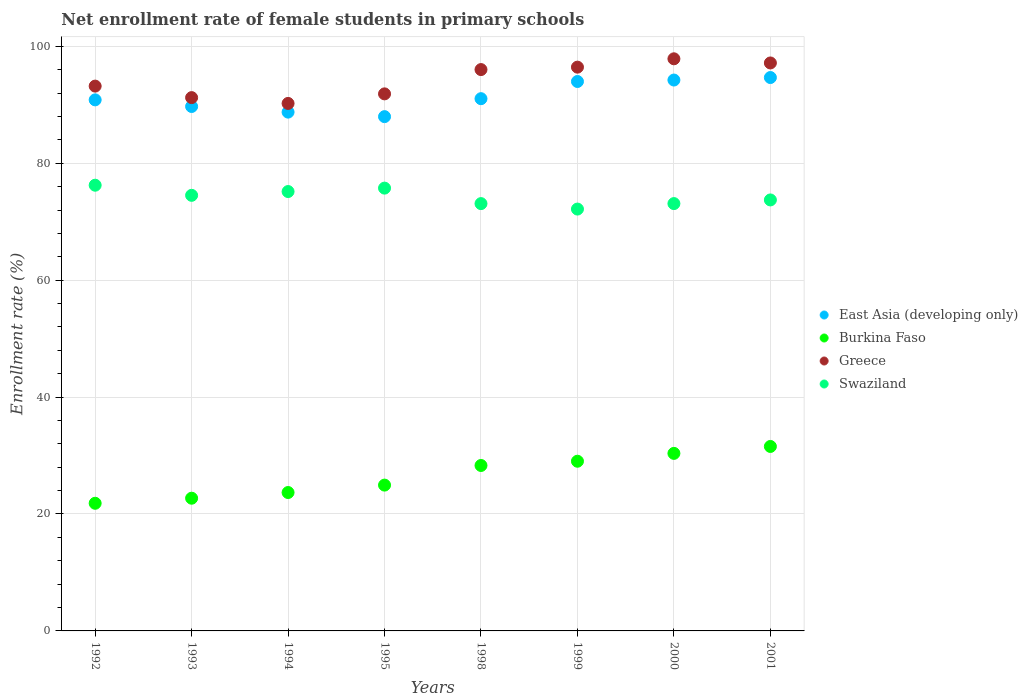Is the number of dotlines equal to the number of legend labels?
Give a very brief answer. Yes. What is the net enrollment rate of female students in primary schools in Swaziland in 1994?
Offer a terse response. 75.16. Across all years, what is the maximum net enrollment rate of female students in primary schools in Greece?
Your response must be concise. 97.86. Across all years, what is the minimum net enrollment rate of female students in primary schools in Swaziland?
Provide a short and direct response. 72.16. What is the total net enrollment rate of female students in primary schools in Swaziland in the graph?
Provide a succinct answer. 593.72. What is the difference between the net enrollment rate of female students in primary schools in Burkina Faso in 1992 and that in 2000?
Offer a terse response. -8.54. What is the difference between the net enrollment rate of female students in primary schools in Swaziland in 1992 and the net enrollment rate of female students in primary schools in Greece in 2000?
Make the answer very short. -21.62. What is the average net enrollment rate of female students in primary schools in Greece per year?
Offer a terse response. 94.25. In the year 1994, what is the difference between the net enrollment rate of female students in primary schools in Burkina Faso and net enrollment rate of female students in primary schools in East Asia (developing only)?
Offer a terse response. -65.07. What is the ratio of the net enrollment rate of female students in primary schools in Greece in 1993 to that in 2000?
Keep it short and to the point. 0.93. What is the difference between the highest and the second highest net enrollment rate of female students in primary schools in East Asia (developing only)?
Ensure brevity in your answer.  0.43. What is the difference between the highest and the lowest net enrollment rate of female students in primary schools in Greece?
Ensure brevity in your answer.  7.63. Is the sum of the net enrollment rate of female students in primary schools in Swaziland in 1992 and 2001 greater than the maximum net enrollment rate of female students in primary schools in East Asia (developing only) across all years?
Provide a succinct answer. Yes. Does the net enrollment rate of female students in primary schools in Burkina Faso monotonically increase over the years?
Keep it short and to the point. Yes. Is the net enrollment rate of female students in primary schools in Swaziland strictly greater than the net enrollment rate of female students in primary schools in East Asia (developing only) over the years?
Your answer should be very brief. No. How many dotlines are there?
Your answer should be compact. 4. How many years are there in the graph?
Your response must be concise. 8. What is the difference between two consecutive major ticks on the Y-axis?
Offer a terse response. 20. Are the values on the major ticks of Y-axis written in scientific E-notation?
Make the answer very short. No. Does the graph contain any zero values?
Provide a short and direct response. No. Does the graph contain grids?
Your answer should be compact. Yes. How many legend labels are there?
Provide a short and direct response. 4. How are the legend labels stacked?
Offer a very short reply. Vertical. What is the title of the graph?
Make the answer very short. Net enrollment rate of female students in primary schools. Does "Djibouti" appear as one of the legend labels in the graph?
Provide a short and direct response. No. What is the label or title of the Y-axis?
Offer a terse response. Enrollment rate (%). What is the Enrollment rate (%) in East Asia (developing only) in 1992?
Offer a very short reply. 90.84. What is the Enrollment rate (%) of Burkina Faso in 1992?
Give a very brief answer. 21.83. What is the Enrollment rate (%) in Greece in 1992?
Give a very brief answer. 93.19. What is the Enrollment rate (%) in Swaziland in 1992?
Provide a short and direct response. 76.24. What is the Enrollment rate (%) in East Asia (developing only) in 1993?
Your answer should be very brief. 89.71. What is the Enrollment rate (%) in Burkina Faso in 1993?
Provide a short and direct response. 22.7. What is the Enrollment rate (%) in Greece in 1993?
Provide a succinct answer. 91.22. What is the Enrollment rate (%) in Swaziland in 1993?
Your answer should be very brief. 74.51. What is the Enrollment rate (%) of East Asia (developing only) in 1994?
Your answer should be very brief. 88.74. What is the Enrollment rate (%) in Burkina Faso in 1994?
Make the answer very short. 23.67. What is the Enrollment rate (%) of Greece in 1994?
Make the answer very short. 90.23. What is the Enrollment rate (%) in Swaziland in 1994?
Make the answer very short. 75.16. What is the Enrollment rate (%) in East Asia (developing only) in 1995?
Offer a very short reply. 87.97. What is the Enrollment rate (%) of Burkina Faso in 1995?
Offer a terse response. 24.94. What is the Enrollment rate (%) in Greece in 1995?
Give a very brief answer. 91.86. What is the Enrollment rate (%) in Swaziland in 1995?
Offer a very short reply. 75.74. What is the Enrollment rate (%) of East Asia (developing only) in 1998?
Offer a very short reply. 91.04. What is the Enrollment rate (%) in Burkina Faso in 1998?
Your answer should be compact. 28.3. What is the Enrollment rate (%) of Greece in 1998?
Your answer should be compact. 96.02. What is the Enrollment rate (%) in Swaziland in 1998?
Offer a very short reply. 73.09. What is the Enrollment rate (%) in East Asia (developing only) in 1999?
Your response must be concise. 93.98. What is the Enrollment rate (%) in Burkina Faso in 1999?
Offer a terse response. 29.03. What is the Enrollment rate (%) in Greece in 1999?
Make the answer very short. 96.44. What is the Enrollment rate (%) of Swaziland in 1999?
Keep it short and to the point. 72.16. What is the Enrollment rate (%) in East Asia (developing only) in 2000?
Offer a terse response. 94.23. What is the Enrollment rate (%) in Burkina Faso in 2000?
Offer a very short reply. 30.37. What is the Enrollment rate (%) of Greece in 2000?
Provide a succinct answer. 97.86. What is the Enrollment rate (%) of Swaziland in 2000?
Provide a succinct answer. 73.1. What is the Enrollment rate (%) of East Asia (developing only) in 2001?
Your answer should be very brief. 94.66. What is the Enrollment rate (%) in Burkina Faso in 2001?
Provide a succinct answer. 31.55. What is the Enrollment rate (%) of Greece in 2001?
Offer a terse response. 97.15. What is the Enrollment rate (%) of Swaziland in 2001?
Your response must be concise. 73.72. Across all years, what is the maximum Enrollment rate (%) in East Asia (developing only)?
Keep it short and to the point. 94.66. Across all years, what is the maximum Enrollment rate (%) of Burkina Faso?
Your answer should be very brief. 31.55. Across all years, what is the maximum Enrollment rate (%) in Greece?
Your answer should be very brief. 97.86. Across all years, what is the maximum Enrollment rate (%) in Swaziland?
Give a very brief answer. 76.24. Across all years, what is the minimum Enrollment rate (%) of East Asia (developing only)?
Make the answer very short. 87.97. Across all years, what is the minimum Enrollment rate (%) of Burkina Faso?
Offer a very short reply. 21.83. Across all years, what is the minimum Enrollment rate (%) of Greece?
Give a very brief answer. 90.23. Across all years, what is the minimum Enrollment rate (%) in Swaziland?
Your answer should be compact. 72.16. What is the total Enrollment rate (%) in East Asia (developing only) in the graph?
Offer a terse response. 731.17. What is the total Enrollment rate (%) of Burkina Faso in the graph?
Offer a very short reply. 212.4. What is the total Enrollment rate (%) in Greece in the graph?
Give a very brief answer. 753.98. What is the total Enrollment rate (%) of Swaziland in the graph?
Make the answer very short. 593.72. What is the difference between the Enrollment rate (%) of East Asia (developing only) in 1992 and that in 1993?
Your answer should be compact. 1.13. What is the difference between the Enrollment rate (%) in Burkina Faso in 1992 and that in 1993?
Make the answer very short. -0.87. What is the difference between the Enrollment rate (%) in Greece in 1992 and that in 1993?
Offer a terse response. 1.97. What is the difference between the Enrollment rate (%) in Swaziland in 1992 and that in 1993?
Your answer should be compact. 1.73. What is the difference between the Enrollment rate (%) of East Asia (developing only) in 1992 and that in 1994?
Offer a terse response. 2.1. What is the difference between the Enrollment rate (%) in Burkina Faso in 1992 and that in 1994?
Make the answer very short. -1.84. What is the difference between the Enrollment rate (%) in Greece in 1992 and that in 1994?
Give a very brief answer. 2.96. What is the difference between the Enrollment rate (%) in Swaziland in 1992 and that in 1994?
Your answer should be very brief. 1.08. What is the difference between the Enrollment rate (%) of East Asia (developing only) in 1992 and that in 1995?
Provide a succinct answer. 2.87. What is the difference between the Enrollment rate (%) of Burkina Faso in 1992 and that in 1995?
Keep it short and to the point. -3.11. What is the difference between the Enrollment rate (%) of Greece in 1992 and that in 1995?
Offer a very short reply. 1.33. What is the difference between the Enrollment rate (%) in Swaziland in 1992 and that in 1995?
Your response must be concise. 0.5. What is the difference between the Enrollment rate (%) of East Asia (developing only) in 1992 and that in 1998?
Ensure brevity in your answer.  -0.2. What is the difference between the Enrollment rate (%) in Burkina Faso in 1992 and that in 1998?
Offer a very short reply. -6.46. What is the difference between the Enrollment rate (%) of Greece in 1992 and that in 1998?
Provide a succinct answer. -2.83. What is the difference between the Enrollment rate (%) of Swaziland in 1992 and that in 1998?
Offer a very short reply. 3.15. What is the difference between the Enrollment rate (%) of East Asia (developing only) in 1992 and that in 1999?
Keep it short and to the point. -3.14. What is the difference between the Enrollment rate (%) of Burkina Faso in 1992 and that in 1999?
Provide a succinct answer. -7.19. What is the difference between the Enrollment rate (%) in Greece in 1992 and that in 1999?
Provide a succinct answer. -3.24. What is the difference between the Enrollment rate (%) in Swaziland in 1992 and that in 1999?
Your answer should be compact. 4.08. What is the difference between the Enrollment rate (%) of East Asia (developing only) in 1992 and that in 2000?
Offer a terse response. -3.39. What is the difference between the Enrollment rate (%) in Burkina Faso in 1992 and that in 2000?
Your response must be concise. -8.54. What is the difference between the Enrollment rate (%) of Greece in 1992 and that in 2000?
Your response must be concise. -4.67. What is the difference between the Enrollment rate (%) in Swaziland in 1992 and that in 2000?
Provide a short and direct response. 3.14. What is the difference between the Enrollment rate (%) in East Asia (developing only) in 1992 and that in 2001?
Make the answer very short. -3.82. What is the difference between the Enrollment rate (%) in Burkina Faso in 1992 and that in 2001?
Your response must be concise. -9.72. What is the difference between the Enrollment rate (%) of Greece in 1992 and that in 2001?
Your answer should be very brief. -3.96. What is the difference between the Enrollment rate (%) in Swaziland in 1992 and that in 2001?
Ensure brevity in your answer.  2.52. What is the difference between the Enrollment rate (%) in East Asia (developing only) in 1993 and that in 1994?
Give a very brief answer. 0.96. What is the difference between the Enrollment rate (%) of Burkina Faso in 1993 and that in 1994?
Give a very brief answer. -0.97. What is the difference between the Enrollment rate (%) in Greece in 1993 and that in 1994?
Ensure brevity in your answer.  0.99. What is the difference between the Enrollment rate (%) of Swaziland in 1993 and that in 1994?
Offer a terse response. -0.65. What is the difference between the Enrollment rate (%) in East Asia (developing only) in 1993 and that in 1995?
Your answer should be compact. 1.74. What is the difference between the Enrollment rate (%) in Burkina Faso in 1993 and that in 1995?
Offer a terse response. -2.24. What is the difference between the Enrollment rate (%) in Greece in 1993 and that in 1995?
Offer a terse response. -0.64. What is the difference between the Enrollment rate (%) of Swaziland in 1993 and that in 1995?
Your answer should be compact. -1.23. What is the difference between the Enrollment rate (%) of East Asia (developing only) in 1993 and that in 1998?
Provide a succinct answer. -1.34. What is the difference between the Enrollment rate (%) in Burkina Faso in 1993 and that in 1998?
Provide a succinct answer. -5.6. What is the difference between the Enrollment rate (%) in Greece in 1993 and that in 1998?
Make the answer very short. -4.8. What is the difference between the Enrollment rate (%) in Swaziland in 1993 and that in 1998?
Give a very brief answer. 1.42. What is the difference between the Enrollment rate (%) in East Asia (developing only) in 1993 and that in 1999?
Give a very brief answer. -4.28. What is the difference between the Enrollment rate (%) of Burkina Faso in 1993 and that in 1999?
Give a very brief answer. -6.33. What is the difference between the Enrollment rate (%) of Greece in 1993 and that in 1999?
Offer a terse response. -5.21. What is the difference between the Enrollment rate (%) in Swaziland in 1993 and that in 1999?
Give a very brief answer. 2.35. What is the difference between the Enrollment rate (%) in East Asia (developing only) in 1993 and that in 2000?
Keep it short and to the point. -4.53. What is the difference between the Enrollment rate (%) in Burkina Faso in 1993 and that in 2000?
Offer a very short reply. -7.67. What is the difference between the Enrollment rate (%) of Greece in 1993 and that in 2000?
Ensure brevity in your answer.  -6.64. What is the difference between the Enrollment rate (%) in Swaziland in 1993 and that in 2000?
Your response must be concise. 1.41. What is the difference between the Enrollment rate (%) in East Asia (developing only) in 1993 and that in 2001?
Ensure brevity in your answer.  -4.95. What is the difference between the Enrollment rate (%) of Burkina Faso in 1993 and that in 2001?
Keep it short and to the point. -8.85. What is the difference between the Enrollment rate (%) of Greece in 1993 and that in 2001?
Provide a short and direct response. -5.93. What is the difference between the Enrollment rate (%) of Swaziland in 1993 and that in 2001?
Give a very brief answer. 0.79. What is the difference between the Enrollment rate (%) in East Asia (developing only) in 1994 and that in 1995?
Give a very brief answer. 0.77. What is the difference between the Enrollment rate (%) of Burkina Faso in 1994 and that in 1995?
Ensure brevity in your answer.  -1.27. What is the difference between the Enrollment rate (%) in Greece in 1994 and that in 1995?
Give a very brief answer. -1.64. What is the difference between the Enrollment rate (%) of Swaziland in 1994 and that in 1995?
Your answer should be compact. -0.58. What is the difference between the Enrollment rate (%) in East Asia (developing only) in 1994 and that in 1998?
Provide a short and direct response. -2.3. What is the difference between the Enrollment rate (%) of Burkina Faso in 1994 and that in 1998?
Give a very brief answer. -4.62. What is the difference between the Enrollment rate (%) of Greece in 1994 and that in 1998?
Provide a short and direct response. -5.79. What is the difference between the Enrollment rate (%) of Swaziland in 1994 and that in 1998?
Offer a terse response. 2.07. What is the difference between the Enrollment rate (%) of East Asia (developing only) in 1994 and that in 1999?
Keep it short and to the point. -5.24. What is the difference between the Enrollment rate (%) in Burkina Faso in 1994 and that in 1999?
Your response must be concise. -5.35. What is the difference between the Enrollment rate (%) in Greece in 1994 and that in 1999?
Give a very brief answer. -6.21. What is the difference between the Enrollment rate (%) of Swaziland in 1994 and that in 1999?
Make the answer very short. 3. What is the difference between the Enrollment rate (%) of East Asia (developing only) in 1994 and that in 2000?
Provide a short and direct response. -5.49. What is the difference between the Enrollment rate (%) in Burkina Faso in 1994 and that in 2000?
Provide a short and direct response. -6.7. What is the difference between the Enrollment rate (%) in Greece in 1994 and that in 2000?
Keep it short and to the point. -7.63. What is the difference between the Enrollment rate (%) in Swaziland in 1994 and that in 2000?
Provide a short and direct response. 2.06. What is the difference between the Enrollment rate (%) of East Asia (developing only) in 1994 and that in 2001?
Offer a terse response. -5.92. What is the difference between the Enrollment rate (%) in Burkina Faso in 1994 and that in 2001?
Your answer should be compact. -7.88. What is the difference between the Enrollment rate (%) in Greece in 1994 and that in 2001?
Make the answer very short. -6.92. What is the difference between the Enrollment rate (%) in Swaziland in 1994 and that in 2001?
Your answer should be very brief. 1.44. What is the difference between the Enrollment rate (%) of East Asia (developing only) in 1995 and that in 1998?
Provide a succinct answer. -3.07. What is the difference between the Enrollment rate (%) of Burkina Faso in 1995 and that in 1998?
Offer a terse response. -3.36. What is the difference between the Enrollment rate (%) of Greece in 1995 and that in 1998?
Keep it short and to the point. -4.16. What is the difference between the Enrollment rate (%) in Swaziland in 1995 and that in 1998?
Your response must be concise. 2.65. What is the difference between the Enrollment rate (%) in East Asia (developing only) in 1995 and that in 1999?
Your answer should be very brief. -6.01. What is the difference between the Enrollment rate (%) of Burkina Faso in 1995 and that in 1999?
Offer a very short reply. -4.08. What is the difference between the Enrollment rate (%) of Greece in 1995 and that in 1999?
Give a very brief answer. -4.57. What is the difference between the Enrollment rate (%) of Swaziland in 1995 and that in 1999?
Your answer should be compact. 3.58. What is the difference between the Enrollment rate (%) in East Asia (developing only) in 1995 and that in 2000?
Keep it short and to the point. -6.26. What is the difference between the Enrollment rate (%) in Burkina Faso in 1995 and that in 2000?
Your response must be concise. -5.43. What is the difference between the Enrollment rate (%) of Greece in 1995 and that in 2000?
Your response must be concise. -6. What is the difference between the Enrollment rate (%) in Swaziland in 1995 and that in 2000?
Offer a very short reply. 2.65. What is the difference between the Enrollment rate (%) in East Asia (developing only) in 1995 and that in 2001?
Offer a terse response. -6.69. What is the difference between the Enrollment rate (%) in Burkina Faso in 1995 and that in 2001?
Provide a succinct answer. -6.61. What is the difference between the Enrollment rate (%) of Greece in 1995 and that in 2001?
Offer a terse response. -5.29. What is the difference between the Enrollment rate (%) in Swaziland in 1995 and that in 2001?
Keep it short and to the point. 2.02. What is the difference between the Enrollment rate (%) of East Asia (developing only) in 1998 and that in 1999?
Offer a terse response. -2.94. What is the difference between the Enrollment rate (%) of Burkina Faso in 1998 and that in 1999?
Keep it short and to the point. -0.73. What is the difference between the Enrollment rate (%) in Greece in 1998 and that in 1999?
Make the answer very short. -0.42. What is the difference between the Enrollment rate (%) in Swaziland in 1998 and that in 1999?
Keep it short and to the point. 0.93. What is the difference between the Enrollment rate (%) of East Asia (developing only) in 1998 and that in 2000?
Make the answer very short. -3.19. What is the difference between the Enrollment rate (%) in Burkina Faso in 1998 and that in 2000?
Provide a short and direct response. -2.07. What is the difference between the Enrollment rate (%) of Greece in 1998 and that in 2000?
Keep it short and to the point. -1.84. What is the difference between the Enrollment rate (%) in Swaziland in 1998 and that in 2000?
Make the answer very short. -0. What is the difference between the Enrollment rate (%) of East Asia (developing only) in 1998 and that in 2001?
Your answer should be very brief. -3.62. What is the difference between the Enrollment rate (%) in Burkina Faso in 1998 and that in 2001?
Provide a succinct answer. -3.26. What is the difference between the Enrollment rate (%) of Greece in 1998 and that in 2001?
Give a very brief answer. -1.13. What is the difference between the Enrollment rate (%) of Swaziland in 1998 and that in 2001?
Give a very brief answer. -0.63. What is the difference between the Enrollment rate (%) of East Asia (developing only) in 1999 and that in 2000?
Offer a terse response. -0.25. What is the difference between the Enrollment rate (%) in Burkina Faso in 1999 and that in 2000?
Offer a terse response. -1.34. What is the difference between the Enrollment rate (%) of Greece in 1999 and that in 2000?
Make the answer very short. -1.43. What is the difference between the Enrollment rate (%) in Swaziland in 1999 and that in 2000?
Make the answer very short. -0.94. What is the difference between the Enrollment rate (%) of East Asia (developing only) in 1999 and that in 2001?
Ensure brevity in your answer.  -0.68. What is the difference between the Enrollment rate (%) of Burkina Faso in 1999 and that in 2001?
Provide a short and direct response. -2.53. What is the difference between the Enrollment rate (%) of Greece in 1999 and that in 2001?
Provide a succinct answer. -0.72. What is the difference between the Enrollment rate (%) in Swaziland in 1999 and that in 2001?
Ensure brevity in your answer.  -1.56. What is the difference between the Enrollment rate (%) in East Asia (developing only) in 2000 and that in 2001?
Offer a very short reply. -0.43. What is the difference between the Enrollment rate (%) in Burkina Faso in 2000 and that in 2001?
Provide a short and direct response. -1.18. What is the difference between the Enrollment rate (%) in Greece in 2000 and that in 2001?
Keep it short and to the point. 0.71. What is the difference between the Enrollment rate (%) of Swaziland in 2000 and that in 2001?
Ensure brevity in your answer.  -0.62. What is the difference between the Enrollment rate (%) of East Asia (developing only) in 1992 and the Enrollment rate (%) of Burkina Faso in 1993?
Your answer should be compact. 68.14. What is the difference between the Enrollment rate (%) in East Asia (developing only) in 1992 and the Enrollment rate (%) in Greece in 1993?
Keep it short and to the point. -0.38. What is the difference between the Enrollment rate (%) in East Asia (developing only) in 1992 and the Enrollment rate (%) in Swaziland in 1993?
Ensure brevity in your answer.  16.33. What is the difference between the Enrollment rate (%) of Burkina Faso in 1992 and the Enrollment rate (%) of Greece in 1993?
Your answer should be very brief. -69.39. What is the difference between the Enrollment rate (%) in Burkina Faso in 1992 and the Enrollment rate (%) in Swaziland in 1993?
Offer a terse response. -52.68. What is the difference between the Enrollment rate (%) of Greece in 1992 and the Enrollment rate (%) of Swaziland in 1993?
Your response must be concise. 18.68. What is the difference between the Enrollment rate (%) of East Asia (developing only) in 1992 and the Enrollment rate (%) of Burkina Faso in 1994?
Provide a succinct answer. 67.17. What is the difference between the Enrollment rate (%) of East Asia (developing only) in 1992 and the Enrollment rate (%) of Greece in 1994?
Keep it short and to the point. 0.61. What is the difference between the Enrollment rate (%) in East Asia (developing only) in 1992 and the Enrollment rate (%) in Swaziland in 1994?
Give a very brief answer. 15.68. What is the difference between the Enrollment rate (%) of Burkina Faso in 1992 and the Enrollment rate (%) of Greece in 1994?
Provide a short and direct response. -68.4. What is the difference between the Enrollment rate (%) of Burkina Faso in 1992 and the Enrollment rate (%) of Swaziland in 1994?
Provide a succinct answer. -53.32. What is the difference between the Enrollment rate (%) of Greece in 1992 and the Enrollment rate (%) of Swaziland in 1994?
Provide a short and direct response. 18.03. What is the difference between the Enrollment rate (%) in East Asia (developing only) in 1992 and the Enrollment rate (%) in Burkina Faso in 1995?
Your answer should be very brief. 65.9. What is the difference between the Enrollment rate (%) of East Asia (developing only) in 1992 and the Enrollment rate (%) of Greece in 1995?
Ensure brevity in your answer.  -1.03. What is the difference between the Enrollment rate (%) in East Asia (developing only) in 1992 and the Enrollment rate (%) in Swaziland in 1995?
Your answer should be compact. 15.1. What is the difference between the Enrollment rate (%) in Burkina Faso in 1992 and the Enrollment rate (%) in Greece in 1995?
Give a very brief answer. -70.03. What is the difference between the Enrollment rate (%) of Burkina Faso in 1992 and the Enrollment rate (%) of Swaziland in 1995?
Your answer should be very brief. -53.91. What is the difference between the Enrollment rate (%) in Greece in 1992 and the Enrollment rate (%) in Swaziland in 1995?
Provide a short and direct response. 17.45. What is the difference between the Enrollment rate (%) of East Asia (developing only) in 1992 and the Enrollment rate (%) of Burkina Faso in 1998?
Your response must be concise. 62.54. What is the difference between the Enrollment rate (%) in East Asia (developing only) in 1992 and the Enrollment rate (%) in Greece in 1998?
Offer a very short reply. -5.18. What is the difference between the Enrollment rate (%) of East Asia (developing only) in 1992 and the Enrollment rate (%) of Swaziland in 1998?
Keep it short and to the point. 17.75. What is the difference between the Enrollment rate (%) in Burkina Faso in 1992 and the Enrollment rate (%) in Greece in 1998?
Offer a very short reply. -74.19. What is the difference between the Enrollment rate (%) in Burkina Faso in 1992 and the Enrollment rate (%) in Swaziland in 1998?
Provide a succinct answer. -51.26. What is the difference between the Enrollment rate (%) of Greece in 1992 and the Enrollment rate (%) of Swaziland in 1998?
Provide a short and direct response. 20.1. What is the difference between the Enrollment rate (%) in East Asia (developing only) in 1992 and the Enrollment rate (%) in Burkina Faso in 1999?
Provide a succinct answer. 61.81. What is the difference between the Enrollment rate (%) in East Asia (developing only) in 1992 and the Enrollment rate (%) in Greece in 1999?
Provide a succinct answer. -5.6. What is the difference between the Enrollment rate (%) of East Asia (developing only) in 1992 and the Enrollment rate (%) of Swaziland in 1999?
Provide a succinct answer. 18.68. What is the difference between the Enrollment rate (%) of Burkina Faso in 1992 and the Enrollment rate (%) of Greece in 1999?
Give a very brief answer. -74.6. What is the difference between the Enrollment rate (%) in Burkina Faso in 1992 and the Enrollment rate (%) in Swaziland in 1999?
Provide a short and direct response. -50.33. What is the difference between the Enrollment rate (%) in Greece in 1992 and the Enrollment rate (%) in Swaziland in 1999?
Your response must be concise. 21.03. What is the difference between the Enrollment rate (%) in East Asia (developing only) in 1992 and the Enrollment rate (%) in Burkina Faso in 2000?
Provide a succinct answer. 60.47. What is the difference between the Enrollment rate (%) in East Asia (developing only) in 1992 and the Enrollment rate (%) in Greece in 2000?
Make the answer very short. -7.03. What is the difference between the Enrollment rate (%) in East Asia (developing only) in 1992 and the Enrollment rate (%) in Swaziland in 2000?
Keep it short and to the point. 17.74. What is the difference between the Enrollment rate (%) in Burkina Faso in 1992 and the Enrollment rate (%) in Greece in 2000?
Ensure brevity in your answer.  -76.03. What is the difference between the Enrollment rate (%) in Burkina Faso in 1992 and the Enrollment rate (%) in Swaziland in 2000?
Give a very brief answer. -51.26. What is the difference between the Enrollment rate (%) of Greece in 1992 and the Enrollment rate (%) of Swaziland in 2000?
Offer a very short reply. 20.1. What is the difference between the Enrollment rate (%) in East Asia (developing only) in 1992 and the Enrollment rate (%) in Burkina Faso in 2001?
Provide a short and direct response. 59.28. What is the difference between the Enrollment rate (%) of East Asia (developing only) in 1992 and the Enrollment rate (%) of Greece in 2001?
Provide a short and direct response. -6.31. What is the difference between the Enrollment rate (%) in East Asia (developing only) in 1992 and the Enrollment rate (%) in Swaziland in 2001?
Provide a succinct answer. 17.12. What is the difference between the Enrollment rate (%) in Burkina Faso in 1992 and the Enrollment rate (%) in Greece in 2001?
Make the answer very short. -75.32. What is the difference between the Enrollment rate (%) of Burkina Faso in 1992 and the Enrollment rate (%) of Swaziland in 2001?
Your answer should be very brief. -51.89. What is the difference between the Enrollment rate (%) of Greece in 1992 and the Enrollment rate (%) of Swaziland in 2001?
Offer a terse response. 19.47. What is the difference between the Enrollment rate (%) of East Asia (developing only) in 1993 and the Enrollment rate (%) of Burkina Faso in 1994?
Offer a very short reply. 66.03. What is the difference between the Enrollment rate (%) in East Asia (developing only) in 1993 and the Enrollment rate (%) in Greece in 1994?
Give a very brief answer. -0.52. What is the difference between the Enrollment rate (%) of East Asia (developing only) in 1993 and the Enrollment rate (%) of Swaziland in 1994?
Your response must be concise. 14.55. What is the difference between the Enrollment rate (%) of Burkina Faso in 1993 and the Enrollment rate (%) of Greece in 1994?
Ensure brevity in your answer.  -67.53. What is the difference between the Enrollment rate (%) of Burkina Faso in 1993 and the Enrollment rate (%) of Swaziland in 1994?
Make the answer very short. -52.46. What is the difference between the Enrollment rate (%) of Greece in 1993 and the Enrollment rate (%) of Swaziland in 1994?
Make the answer very short. 16.06. What is the difference between the Enrollment rate (%) of East Asia (developing only) in 1993 and the Enrollment rate (%) of Burkina Faso in 1995?
Your response must be concise. 64.76. What is the difference between the Enrollment rate (%) in East Asia (developing only) in 1993 and the Enrollment rate (%) in Greece in 1995?
Provide a short and direct response. -2.16. What is the difference between the Enrollment rate (%) of East Asia (developing only) in 1993 and the Enrollment rate (%) of Swaziland in 1995?
Ensure brevity in your answer.  13.96. What is the difference between the Enrollment rate (%) in Burkina Faso in 1993 and the Enrollment rate (%) in Greece in 1995?
Your answer should be very brief. -69.16. What is the difference between the Enrollment rate (%) in Burkina Faso in 1993 and the Enrollment rate (%) in Swaziland in 1995?
Offer a very short reply. -53.04. What is the difference between the Enrollment rate (%) in Greece in 1993 and the Enrollment rate (%) in Swaziland in 1995?
Make the answer very short. 15.48. What is the difference between the Enrollment rate (%) in East Asia (developing only) in 1993 and the Enrollment rate (%) in Burkina Faso in 1998?
Offer a terse response. 61.41. What is the difference between the Enrollment rate (%) of East Asia (developing only) in 1993 and the Enrollment rate (%) of Greece in 1998?
Give a very brief answer. -6.31. What is the difference between the Enrollment rate (%) in East Asia (developing only) in 1993 and the Enrollment rate (%) in Swaziland in 1998?
Ensure brevity in your answer.  16.61. What is the difference between the Enrollment rate (%) in Burkina Faso in 1993 and the Enrollment rate (%) in Greece in 1998?
Your answer should be compact. -73.32. What is the difference between the Enrollment rate (%) of Burkina Faso in 1993 and the Enrollment rate (%) of Swaziland in 1998?
Your answer should be very brief. -50.39. What is the difference between the Enrollment rate (%) of Greece in 1993 and the Enrollment rate (%) of Swaziland in 1998?
Give a very brief answer. 18.13. What is the difference between the Enrollment rate (%) of East Asia (developing only) in 1993 and the Enrollment rate (%) of Burkina Faso in 1999?
Offer a terse response. 60.68. What is the difference between the Enrollment rate (%) in East Asia (developing only) in 1993 and the Enrollment rate (%) in Greece in 1999?
Your answer should be very brief. -6.73. What is the difference between the Enrollment rate (%) in East Asia (developing only) in 1993 and the Enrollment rate (%) in Swaziland in 1999?
Your answer should be very brief. 17.55. What is the difference between the Enrollment rate (%) of Burkina Faso in 1993 and the Enrollment rate (%) of Greece in 1999?
Offer a very short reply. -73.73. What is the difference between the Enrollment rate (%) of Burkina Faso in 1993 and the Enrollment rate (%) of Swaziland in 1999?
Keep it short and to the point. -49.46. What is the difference between the Enrollment rate (%) of Greece in 1993 and the Enrollment rate (%) of Swaziland in 1999?
Offer a very short reply. 19.06. What is the difference between the Enrollment rate (%) in East Asia (developing only) in 1993 and the Enrollment rate (%) in Burkina Faso in 2000?
Keep it short and to the point. 59.34. What is the difference between the Enrollment rate (%) in East Asia (developing only) in 1993 and the Enrollment rate (%) in Greece in 2000?
Keep it short and to the point. -8.16. What is the difference between the Enrollment rate (%) of East Asia (developing only) in 1993 and the Enrollment rate (%) of Swaziland in 2000?
Your response must be concise. 16.61. What is the difference between the Enrollment rate (%) in Burkina Faso in 1993 and the Enrollment rate (%) in Greece in 2000?
Offer a very short reply. -75.16. What is the difference between the Enrollment rate (%) in Burkina Faso in 1993 and the Enrollment rate (%) in Swaziland in 2000?
Provide a succinct answer. -50.4. What is the difference between the Enrollment rate (%) in Greece in 1993 and the Enrollment rate (%) in Swaziland in 2000?
Offer a terse response. 18.13. What is the difference between the Enrollment rate (%) of East Asia (developing only) in 1993 and the Enrollment rate (%) of Burkina Faso in 2001?
Ensure brevity in your answer.  58.15. What is the difference between the Enrollment rate (%) of East Asia (developing only) in 1993 and the Enrollment rate (%) of Greece in 2001?
Ensure brevity in your answer.  -7.45. What is the difference between the Enrollment rate (%) in East Asia (developing only) in 1993 and the Enrollment rate (%) in Swaziland in 2001?
Make the answer very short. 15.98. What is the difference between the Enrollment rate (%) of Burkina Faso in 1993 and the Enrollment rate (%) of Greece in 2001?
Your response must be concise. -74.45. What is the difference between the Enrollment rate (%) in Burkina Faso in 1993 and the Enrollment rate (%) in Swaziland in 2001?
Your response must be concise. -51.02. What is the difference between the Enrollment rate (%) of Greece in 1993 and the Enrollment rate (%) of Swaziland in 2001?
Provide a succinct answer. 17.5. What is the difference between the Enrollment rate (%) in East Asia (developing only) in 1994 and the Enrollment rate (%) in Burkina Faso in 1995?
Your response must be concise. 63.8. What is the difference between the Enrollment rate (%) in East Asia (developing only) in 1994 and the Enrollment rate (%) in Greece in 1995?
Your answer should be very brief. -3.12. What is the difference between the Enrollment rate (%) in East Asia (developing only) in 1994 and the Enrollment rate (%) in Swaziland in 1995?
Ensure brevity in your answer.  13. What is the difference between the Enrollment rate (%) of Burkina Faso in 1994 and the Enrollment rate (%) of Greece in 1995?
Provide a short and direct response. -68.19. What is the difference between the Enrollment rate (%) in Burkina Faso in 1994 and the Enrollment rate (%) in Swaziland in 1995?
Your response must be concise. -52.07. What is the difference between the Enrollment rate (%) in Greece in 1994 and the Enrollment rate (%) in Swaziland in 1995?
Provide a short and direct response. 14.49. What is the difference between the Enrollment rate (%) of East Asia (developing only) in 1994 and the Enrollment rate (%) of Burkina Faso in 1998?
Ensure brevity in your answer.  60.44. What is the difference between the Enrollment rate (%) in East Asia (developing only) in 1994 and the Enrollment rate (%) in Greece in 1998?
Keep it short and to the point. -7.28. What is the difference between the Enrollment rate (%) in East Asia (developing only) in 1994 and the Enrollment rate (%) in Swaziland in 1998?
Provide a succinct answer. 15.65. What is the difference between the Enrollment rate (%) of Burkina Faso in 1994 and the Enrollment rate (%) of Greece in 1998?
Offer a very short reply. -72.35. What is the difference between the Enrollment rate (%) in Burkina Faso in 1994 and the Enrollment rate (%) in Swaziland in 1998?
Provide a short and direct response. -49.42. What is the difference between the Enrollment rate (%) of Greece in 1994 and the Enrollment rate (%) of Swaziland in 1998?
Ensure brevity in your answer.  17.14. What is the difference between the Enrollment rate (%) of East Asia (developing only) in 1994 and the Enrollment rate (%) of Burkina Faso in 1999?
Your answer should be very brief. 59.72. What is the difference between the Enrollment rate (%) of East Asia (developing only) in 1994 and the Enrollment rate (%) of Greece in 1999?
Your answer should be very brief. -7.69. What is the difference between the Enrollment rate (%) in East Asia (developing only) in 1994 and the Enrollment rate (%) in Swaziland in 1999?
Your response must be concise. 16.58. What is the difference between the Enrollment rate (%) in Burkina Faso in 1994 and the Enrollment rate (%) in Greece in 1999?
Provide a succinct answer. -72.76. What is the difference between the Enrollment rate (%) of Burkina Faso in 1994 and the Enrollment rate (%) of Swaziland in 1999?
Offer a terse response. -48.49. What is the difference between the Enrollment rate (%) in Greece in 1994 and the Enrollment rate (%) in Swaziland in 1999?
Keep it short and to the point. 18.07. What is the difference between the Enrollment rate (%) of East Asia (developing only) in 1994 and the Enrollment rate (%) of Burkina Faso in 2000?
Your response must be concise. 58.37. What is the difference between the Enrollment rate (%) of East Asia (developing only) in 1994 and the Enrollment rate (%) of Greece in 2000?
Give a very brief answer. -9.12. What is the difference between the Enrollment rate (%) in East Asia (developing only) in 1994 and the Enrollment rate (%) in Swaziland in 2000?
Make the answer very short. 15.65. What is the difference between the Enrollment rate (%) of Burkina Faso in 1994 and the Enrollment rate (%) of Greece in 2000?
Keep it short and to the point. -74.19. What is the difference between the Enrollment rate (%) of Burkina Faso in 1994 and the Enrollment rate (%) of Swaziland in 2000?
Ensure brevity in your answer.  -49.42. What is the difference between the Enrollment rate (%) in Greece in 1994 and the Enrollment rate (%) in Swaziland in 2000?
Offer a terse response. 17.13. What is the difference between the Enrollment rate (%) of East Asia (developing only) in 1994 and the Enrollment rate (%) of Burkina Faso in 2001?
Give a very brief answer. 57.19. What is the difference between the Enrollment rate (%) of East Asia (developing only) in 1994 and the Enrollment rate (%) of Greece in 2001?
Your answer should be very brief. -8.41. What is the difference between the Enrollment rate (%) in East Asia (developing only) in 1994 and the Enrollment rate (%) in Swaziland in 2001?
Provide a short and direct response. 15.02. What is the difference between the Enrollment rate (%) of Burkina Faso in 1994 and the Enrollment rate (%) of Greece in 2001?
Offer a terse response. -73.48. What is the difference between the Enrollment rate (%) in Burkina Faso in 1994 and the Enrollment rate (%) in Swaziland in 2001?
Offer a very short reply. -50.05. What is the difference between the Enrollment rate (%) in Greece in 1994 and the Enrollment rate (%) in Swaziland in 2001?
Give a very brief answer. 16.51. What is the difference between the Enrollment rate (%) of East Asia (developing only) in 1995 and the Enrollment rate (%) of Burkina Faso in 1998?
Your answer should be very brief. 59.67. What is the difference between the Enrollment rate (%) in East Asia (developing only) in 1995 and the Enrollment rate (%) in Greece in 1998?
Ensure brevity in your answer.  -8.05. What is the difference between the Enrollment rate (%) in East Asia (developing only) in 1995 and the Enrollment rate (%) in Swaziland in 1998?
Your answer should be compact. 14.88. What is the difference between the Enrollment rate (%) of Burkina Faso in 1995 and the Enrollment rate (%) of Greece in 1998?
Provide a short and direct response. -71.08. What is the difference between the Enrollment rate (%) of Burkina Faso in 1995 and the Enrollment rate (%) of Swaziland in 1998?
Your answer should be compact. -48.15. What is the difference between the Enrollment rate (%) in Greece in 1995 and the Enrollment rate (%) in Swaziland in 1998?
Offer a very short reply. 18.77. What is the difference between the Enrollment rate (%) in East Asia (developing only) in 1995 and the Enrollment rate (%) in Burkina Faso in 1999?
Give a very brief answer. 58.94. What is the difference between the Enrollment rate (%) of East Asia (developing only) in 1995 and the Enrollment rate (%) of Greece in 1999?
Provide a short and direct response. -8.47. What is the difference between the Enrollment rate (%) of East Asia (developing only) in 1995 and the Enrollment rate (%) of Swaziland in 1999?
Offer a very short reply. 15.81. What is the difference between the Enrollment rate (%) of Burkina Faso in 1995 and the Enrollment rate (%) of Greece in 1999?
Provide a short and direct response. -71.49. What is the difference between the Enrollment rate (%) of Burkina Faso in 1995 and the Enrollment rate (%) of Swaziland in 1999?
Offer a very short reply. -47.22. What is the difference between the Enrollment rate (%) of Greece in 1995 and the Enrollment rate (%) of Swaziland in 1999?
Ensure brevity in your answer.  19.7. What is the difference between the Enrollment rate (%) of East Asia (developing only) in 1995 and the Enrollment rate (%) of Burkina Faso in 2000?
Keep it short and to the point. 57.6. What is the difference between the Enrollment rate (%) of East Asia (developing only) in 1995 and the Enrollment rate (%) of Greece in 2000?
Keep it short and to the point. -9.89. What is the difference between the Enrollment rate (%) in East Asia (developing only) in 1995 and the Enrollment rate (%) in Swaziland in 2000?
Provide a short and direct response. 14.87. What is the difference between the Enrollment rate (%) in Burkina Faso in 1995 and the Enrollment rate (%) in Greece in 2000?
Make the answer very short. -72.92. What is the difference between the Enrollment rate (%) in Burkina Faso in 1995 and the Enrollment rate (%) in Swaziland in 2000?
Ensure brevity in your answer.  -48.15. What is the difference between the Enrollment rate (%) of Greece in 1995 and the Enrollment rate (%) of Swaziland in 2000?
Offer a very short reply. 18.77. What is the difference between the Enrollment rate (%) in East Asia (developing only) in 1995 and the Enrollment rate (%) in Burkina Faso in 2001?
Keep it short and to the point. 56.42. What is the difference between the Enrollment rate (%) of East Asia (developing only) in 1995 and the Enrollment rate (%) of Greece in 2001?
Make the answer very short. -9.18. What is the difference between the Enrollment rate (%) of East Asia (developing only) in 1995 and the Enrollment rate (%) of Swaziland in 2001?
Offer a terse response. 14.25. What is the difference between the Enrollment rate (%) of Burkina Faso in 1995 and the Enrollment rate (%) of Greece in 2001?
Offer a very short reply. -72.21. What is the difference between the Enrollment rate (%) of Burkina Faso in 1995 and the Enrollment rate (%) of Swaziland in 2001?
Your answer should be very brief. -48.78. What is the difference between the Enrollment rate (%) in Greece in 1995 and the Enrollment rate (%) in Swaziland in 2001?
Ensure brevity in your answer.  18.14. What is the difference between the Enrollment rate (%) in East Asia (developing only) in 1998 and the Enrollment rate (%) in Burkina Faso in 1999?
Keep it short and to the point. 62.02. What is the difference between the Enrollment rate (%) in East Asia (developing only) in 1998 and the Enrollment rate (%) in Greece in 1999?
Keep it short and to the point. -5.39. What is the difference between the Enrollment rate (%) in East Asia (developing only) in 1998 and the Enrollment rate (%) in Swaziland in 1999?
Your answer should be compact. 18.88. What is the difference between the Enrollment rate (%) of Burkina Faso in 1998 and the Enrollment rate (%) of Greece in 1999?
Your answer should be very brief. -68.14. What is the difference between the Enrollment rate (%) of Burkina Faso in 1998 and the Enrollment rate (%) of Swaziland in 1999?
Give a very brief answer. -43.86. What is the difference between the Enrollment rate (%) in Greece in 1998 and the Enrollment rate (%) in Swaziland in 1999?
Keep it short and to the point. 23.86. What is the difference between the Enrollment rate (%) in East Asia (developing only) in 1998 and the Enrollment rate (%) in Burkina Faso in 2000?
Provide a succinct answer. 60.67. What is the difference between the Enrollment rate (%) of East Asia (developing only) in 1998 and the Enrollment rate (%) of Greece in 2000?
Provide a succinct answer. -6.82. What is the difference between the Enrollment rate (%) of East Asia (developing only) in 1998 and the Enrollment rate (%) of Swaziland in 2000?
Your answer should be compact. 17.94. What is the difference between the Enrollment rate (%) in Burkina Faso in 1998 and the Enrollment rate (%) in Greece in 2000?
Provide a short and direct response. -69.57. What is the difference between the Enrollment rate (%) in Burkina Faso in 1998 and the Enrollment rate (%) in Swaziland in 2000?
Ensure brevity in your answer.  -44.8. What is the difference between the Enrollment rate (%) in Greece in 1998 and the Enrollment rate (%) in Swaziland in 2000?
Offer a terse response. 22.92. What is the difference between the Enrollment rate (%) of East Asia (developing only) in 1998 and the Enrollment rate (%) of Burkina Faso in 2001?
Keep it short and to the point. 59.49. What is the difference between the Enrollment rate (%) in East Asia (developing only) in 1998 and the Enrollment rate (%) in Greece in 2001?
Ensure brevity in your answer.  -6.11. What is the difference between the Enrollment rate (%) in East Asia (developing only) in 1998 and the Enrollment rate (%) in Swaziland in 2001?
Make the answer very short. 17.32. What is the difference between the Enrollment rate (%) of Burkina Faso in 1998 and the Enrollment rate (%) of Greece in 2001?
Provide a succinct answer. -68.85. What is the difference between the Enrollment rate (%) in Burkina Faso in 1998 and the Enrollment rate (%) in Swaziland in 2001?
Give a very brief answer. -45.42. What is the difference between the Enrollment rate (%) of Greece in 1998 and the Enrollment rate (%) of Swaziland in 2001?
Your answer should be very brief. 22.3. What is the difference between the Enrollment rate (%) in East Asia (developing only) in 1999 and the Enrollment rate (%) in Burkina Faso in 2000?
Ensure brevity in your answer.  63.61. What is the difference between the Enrollment rate (%) of East Asia (developing only) in 1999 and the Enrollment rate (%) of Greece in 2000?
Your response must be concise. -3.88. What is the difference between the Enrollment rate (%) of East Asia (developing only) in 1999 and the Enrollment rate (%) of Swaziland in 2000?
Keep it short and to the point. 20.88. What is the difference between the Enrollment rate (%) in Burkina Faso in 1999 and the Enrollment rate (%) in Greece in 2000?
Ensure brevity in your answer.  -68.84. What is the difference between the Enrollment rate (%) of Burkina Faso in 1999 and the Enrollment rate (%) of Swaziland in 2000?
Provide a succinct answer. -44.07. What is the difference between the Enrollment rate (%) in Greece in 1999 and the Enrollment rate (%) in Swaziland in 2000?
Make the answer very short. 23.34. What is the difference between the Enrollment rate (%) of East Asia (developing only) in 1999 and the Enrollment rate (%) of Burkina Faso in 2001?
Your response must be concise. 62.43. What is the difference between the Enrollment rate (%) in East Asia (developing only) in 1999 and the Enrollment rate (%) in Greece in 2001?
Provide a short and direct response. -3.17. What is the difference between the Enrollment rate (%) in East Asia (developing only) in 1999 and the Enrollment rate (%) in Swaziland in 2001?
Offer a very short reply. 20.26. What is the difference between the Enrollment rate (%) in Burkina Faso in 1999 and the Enrollment rate (%) in Greece in 2001?
Provide a short and direct response. -68.13. What is the difference between the Enrollment rate (%) of Burkina Faso in 1999 and the Enrollment rate (%) of Swaziland in 2001?
Provide a short and direct response. -44.7. What is the difference between the Enrollment rate (%) of Greece in 1999 and the Enrollment rate (%) of Swaziland in 2001?
Your answer should be very brief. 22.71. What is the difference between the Enrollment rate (%) in East Asia (developing only) in 2000 and the Enrollment rate (%) in Burkina Faso in 2001?
Provide a succinct answer. 62.68. What is the difference between the Enrollment rate (%) of East Asia (developing only) in 2000 and the Enrollment rate (%) of Greece in 2001?
Your response must be concise. -2.92. What is the difference between the Enrollment rate (%) in East Asia (developing only) in 2000 and the Enrollment rate (%) in Swaziland in 2001?
Make the answer very short. 20.51. What is the difference between the Enrollment rate (%) of Burkina Faso in 2000 and the Enrollment rate (%) of Greece in 2001?
Give a very brief answer. -66.78. What is the difference between the Enrollment rate (%) of Burkina Faso in 2000 and the Enrollment rate (%) of Swaziland in 2001?
Provide a short and direct response. -43.35. What is the difference between the Enrollment rate (%) in Greece in 2000 and the Enrollment rate (%) in Swaziland in 2001?
Provide a succinct answer. 24.14. What is the average Enrollment rate (%) in East Asia (developing only) per year?
Give a very brief answer. 91.4. What is the average Enrollment rate (%) in Burkina Faso per year?
Provide a succinct answer. 26.55. What is the average Enrollment rate (%) of Greece per year?
Provide a succinct answer. 94.25. What is the average Enrollment rate (%) of Swaziland per year?
Keep it short and to the point. 74.22. In the year 1992, what is the difference between the Enrollment rate (%) of East Asia (developing only) and Enrollment rate (%) of Burkina Faso?
Keep it short and to the point. 69. In the year 1992, what is the difference between the Enrollment rate (%) in East Asia (developing only) and Enrollment rate (%) in Greece?
Provide a short and direct response. -2.35. In the year 1992, what is the difference between the Enrollment rate (%) of East Asia (developing only) and Enrollment rate (%) of Swaziland?
Offer a very short reply. 14.6. In the year 1992, what is the difference between the Enrollment rate (%) of Burkina Faso and Enrollment rate (%) of Greece?
Offer a terse response. -71.36. In the year 1992, what is the difference between the Enrollment rate (%) of Burkina Faso and Enrollment rate (%) of Swaziland?
Offer a terse response. -54.41. In the year 1992, what is the difference between the Enrollment rate (%) in Greece and Enrollment rate (%) in Swaziland?
Give a very brief answer. 16.95. In the year 1993, what is the difference between the Enrollment rate (%) of East Asia (developing only) and Enrollment rate (%) of Burkina Faso?
Give a very brief answer. 67. In the year 1993, what is the difference between the Enrollment rate (%) of East Asia (developing only) and Enrollment rate (%) of Greece?
Ensure brevity in your answer.  -1.52. In the year 1993, what is the difference between the Enrollment rate (%) of East Asia (developing only) and Enrollment rate (%) of Swaziland?
Make the answer very short. 15.2. In the year 1993, what is the difference between the Enrollment rate (%) of Burkina Faso and Enrollment rate (%) of Greece?
Your response must be concise. -68.52. In the year 1993, what is the difference between the Enrollment rate (%) of Burkina Faso and Enrollment rate (%) of Swaziland?
Your answer should be compact. -51.81. In the year 1993, what is the difference between the Enrollment rate (%) of Greece and Enrollment rate (%) of Swaziland?
Provide a short and direct response. 16.71. In the year 1994, what is the difference between the Enrollment rate (%) in East Asia (developing only) and Enrollment rate (%) in Burkina Faso?
Offer a terse response. 65.07. In the year 1994, what is the difference between the Enrollment rate (%) of East Asia (developing only) and Enrollment rate (%) of Greece?
Your answer should be compact. -1.49. In the year 1994, what is the difference between the Enrollment rate (%) in East Asia (developing only) and Enrollment rate (%) in Swaziland?
Offer a terse response. 13.58. In the year 1994, what is the difference between the Enrollment rate (%) in Burkina Faso and Enrollment rate (%) in Greece?
Your answer should be compact. -66.56. In the year 1994, what is the difference between the Enrollment rate (%) of Burkina Faso and Enrollment rate (%) of Swaziland?
Your answer should be compact. -51.48. In the year 1994, what is the difference between the Enrollment rate (%) in Greece and Enrollment rate (%) in Swaziland?
Your answer should be very brief. 15.07. In the year 1995, what is the difference between the Enrollment rate (%) in East Asia (developing only) and Enrollment rate (%) in Burkina Faso?
Your answer should be very brief. 63.03. In the year 1995, what is the difference between the Enrollment rate (%) in East Asia (developing only) and Enrollment rate (%) in Greece?
Your answer should be compact. -3.89. In the year 1995, what is the difference between the Enrollment rate (%) in East Asia (developing only) and Enrollment rate (%) in Swaziland?
Your answer should be very brief. 12.23. In the year 1995, what is the difference between the Enrollment rate (%) of Burkina Faso and Enrollment rate (%) of Greece?
Your response must be concise. -66.92. In the year 1995, what is the difference between the Enrollment rate (%) in Burkina Faso and Enrollment rate (%) in Swaziland?
Provide a short and direct response. -50.8. In the year 1995, what is the difference between the Enrollment rate (%) in Greece and Enrollment rate (%) in Swaziland?
Ensure brevity in your answer.  16.12. In the year 1998, what is the difference between the Enrollment rate (%) in East Asia (developing only) and Enrollment rate (%) in Burkina Faso?
Offer a terse response. 62.74. In the year 1998, what is the difference between the Enrollment rate (%) in East Asia (developing only) and Enrollment rate (%) in Greece?
Provide a short and direct response. -4.98. In the year 1998, what is the difference between the Enrollment rate (%) of East Asia (developing only) and Enrollment rate (%) of Swaziland?
Provide a short and direct response. 17.95. In the year 1998, what is the difference between the Enrollment rate (%) in Burkina Faso and Enrollment rate (%) in Greece?
Offer a terse response. -67.72. In the year 1998, what is the difference between the Enrollment rate (%) in Burkina Faso and Enrollment rate (%) in Swaziland?
Keep it short and to the point. -44.79. In the year 1998, what is the difference between the Enrollment rate (%) of Greece and Enrollment rate (%) of Swaziland?
Your response must be concise. 22.93. In the year 1999, what is the difference between the Enrollment rate (%) in East Asia (developing only) and Enrollment rate (%) in Burkina Faso?
Offer a very short reply. 64.95. In the year 1999, what is the difference between the Enrollment rate (%) of East Asia (developing only) and Enrollment rate (%) of Greece?
Ensure brevity in your answer.  -2.45. In the year 1999, what is the difference between the Enrollment rate (%) of East Asia (developing only) and Enrollment rate (%) of Swaziland?
Your response must be concise. 21.82. In the year 1999, what is the difference between the Enrollment rate (%) in Burkina Faso and Enrollment rate (%) in Greece?
Provide a succinct answer. -67.41. In the year 1999, what is the difference between the Enrollment rate (%) in Burkina Faso and Enrollment rate (%) in Swaziland?
Your response must be concise. -43.13. In the year 1999, what is the difference between the Enrollment rate (%) in Greece and Enrollment rate (%) in Swaziland?
Provide a short and direct response. 24.28. In the year 2000, what is the difference between the Enrollment rate (%) in East Asia (developing only) and Enrollment rate (%) in Burkina Faso?
Offer a very short reply. 63.86. In the year 2000, what is the difference between the Enrollment rate (%) of East Asia (developing only) and Enrollment rate (%) of Greece?
Give a very brief answer. -3.63. In the year 2000, what is the difference between the Enrollment rate (%) in East Asia (developing only) and Enrollment rate (%) in Swaziland?
Keep it short and to the point. 21.13. In the year 2000, what is the difference between the Enrollment rate (%) of Burkina Faso and Enrollment rate (%) of Greece?
Offer a terse response. -67.49. In the year 2000, what is the difference between the Enrollment rate (%) in Burkina Faso and Enrollment rate (%) in Swaziland?
Provide a succinct answer. -42.73. In the year 2000, what is the difference between the Enrollment rate (%) in Greece and Enrollment rate (%) in Swaziland?
Your answer should be compact. 24.77. In the year 2001, what is the difference between the Enrollment rate (%) of East Asia (developing only) and Enrollment rate (%) of Burkina Faso?
Give a very brief answer. 63.11. In the year 2001, what is the difference between the Enrollment rate (%) in East Asia (developing only) and Enrollment rate (%) in Greece?
Your answer should be very brief. -2.49. In the year 2001, what is the difference between the Enrollment rate (%) in East Asia (developing only) and Enrollment rate (%) in Swaziland?
Offer a very short reply. 20.94. In the year 2001, what is the difference between the Enrollment rate (%) in Burkina Faso and Enrollment rate (%) in Greece?
Your answer should be very brief. -65.6. In the year 2001, what is the difference between the Enrollment rate (%) in Burkina Faso and Enrollment rate (%) in Swaziland?
Provide a short and direct response. -42.17. In the year 2001, what is the difference between the Enrollment rate (%) in Greece and Enrollment rate (%) in Swaziland?
Offer a terse response. 23.43. What is the ratio of the Enrollment rate (%) in East Asia (developing only) in 1992 to that in 1993?
Give a very brief answer. 1.01. What is the ratio of the Enrollment rate (%) in Burkina Faso in 1992 to that in 1993?
Keep it short and to the point. 0.96. What is the ratio of the Enrollment rate (%) in Greece in 1992 to that in 1993?
Your answer should be very brief. 1.02. What is the ratio of the Enrollment rate (%) in Swaziland in 1992 to that in 1993?
Offer a very short reply. 1.02. What is the ratio of the Enrollment rate (%) in East Asia (developing only) in 1992 to that in 1994?
Offer a terse response. 1.02. What is the ratio of the Enrollment rate (%) in Burkina Faso in 1992 to that in 1994?
Provide a short and direct response. 0.92. What is the ratio of the Enrollment rate (%) in Greece in 1992 to that in 1994?
Give a very brief answer. 1.03. What is the ratio of the Enrollment rate (%) of Swaziland in 1992 to that in 1994?
Your response must be concise. 1.01. What is the ratio of the Enrollment rate (%) in East Asia (developing only) in 1992 to that in 1995?
Your answer should be very brief. 1.03. What is the ratio of the Enrollment rate (%) of Burkina Faso in 1992 to that in 1995?
Your answer should be compact. 0.88. What is the ratio of the Enrollment rate (%) in Greece in 1992 to that in 1995?
Ensure brevity in your answer.  1.01. What is the ratio of the Enrollment rate (%) in Swaziland in 1992 to that in 1995?
Offer a very short reply. 1.01. What is the ratio of the Enrollment rate (%) of Burkina Faso in 1992 to that in 1998?
Give a very brief answer. 0.77. What is the ratio of the Enrollment rate (%) of Greece in 1992 to that in 1998?
Your response must be concise. 0.97. What is the ratio of the Enrollment rate (%) of Swaziland in 1992 to that in 1998?
Provide a succinct answer. 1.04. What is the ratio of the Enrollment rate (%) in East Asia (developing only) in 1992 to that in 1999?
Provide a short and direct response. 0.97. What is the ratio of the Enrollment rate (%) of Burkina Faso in 1992 to that in 1999?
Offer a terse response. 0.75. What is the ratio of the Enrollment rate (%) in Greece in 1992 to that in 1999?
Make the answer very short. 0.97. What is the ratio of the Enrollment rate (%) of Swaziland in 1992 to that in 1999?
Your answer should be compact. 1.06. What is the ratio of the Enrollment rate (%) of Burkina Faso in 1992 to that in 2000?
Offer a very short reply. 0.72. What is the ratio of the Enrollment rate (%) of Greece in 1992 to that in 2000?
Provide a short and direct response. 0.95. What is the ratio of the Enrollment rate (%) of Swaziland in 1992 to that in 2000?
Give a very brief answer. 1.04. What is the ratio of the Enrollment rate (%) of East Asia (developing only) in 1992 to that in 2001?
Provide a short and direct response. 0.96. What is the ratio of the Enrollment rate (%) in Burkina Faso in 1992 to that in 2001?
Give a very brief answer. 0.69. What is the ratio of the Enrollment rate (%) in Greece in 1992 to that in 2001?
Offer a very short reply. 0.96. What is the ratio of the Enrollment rate (%) of Swaziland in 1992 to that in 2001?
Provide a short and direct response. 1.03. What is the ratio of the Enrollment rate (%) in East Asia (developing only) in 1993 to that in 1994?
Ensure brevity in your answer.  1.01. What is the ratio of the Enrollment rate (%) in Burkina Faso in 1993 to that in 1994?
Make the answer very short. 0.96. What is the ratio of the Enrollment rate (%) of East Asia (developing only) in 1993 to that in 1995?
Keep it short and to the point. 1.02. What is the ratio of the Enrollment rate (%) of Burkina Faso in 1993 to that in 1995?
Make the answer very short. 0.91. What is the ratio of the Enrollment rate (%) of Swaziland in 1993 to that in 1995?
Give a very brief answer. 0.98. What is the ratio of the Enrollment rate (%) of East Asia (developing only) in 1993 to that in 1998?
Make the answer very short. 0.99. What is the ratio of the Enrollment rate (%) in Burkina Faso in 1993 to that in 1998?
Provide a short and direct response. 0.8. What is the ratio of the Enrollment rate (%) of Greece in 1993 to that in 1998?
Make the answer very short. 0.95. What is the ratio of the Enrollment rate (%) in Swaziland in 1993 to that in 1998?
Your answer should be compact. 1.02. What is the ratio of the Enrollment rate (%) of East Asia (developing only) in 1993 to that in 1999?
Offer a terse response. 0.95. What is the ratio of the Enrollment rate (%) of Burkina Faso in 1993 to that in 1999?
Offer a terse response. 0.78. What is the ratio of the Enrollment rate (%) in Greece in 1993 to that in 1999?
Your answer should be compact. 0.95. What is the ratio of the Enrollment rate (%) of Swaziland in 1993 to that in 1999?
Make the answer very short. 1.03. What is the ratio of the Enrollment rate (%) in East Asia (developing only) in 1993 to that in 2000?
Offer a very short reply. 0.95. What is the ratio of the Enrollment rate (%) of Burkina Faso in 1993 to that in 2000?
Give a very brief answer. 0.75. What is the ratio of the Enrollment rate (%) of Greece in 1993 to that in 2000?
Provide a short and direct response. 0.93. What is the ratio of the Enrollment rate (%) of Swaziland in 1993 to that in 2000?
Your answer should be compact. 1.02. What is the ratio of the Enrollment rate (%) of East Asia (developing only) in 1993 to that in 2001?
Keep it short and to the point. 0.95. What is the ratio of the Enrollment rate (%) in Burkina Faso in 1993 to that in 2001?
Provide a succinct answer. 0.72. What is the ratio of the Enrollment rate (%) in Greece in 1993 to that in 2001?
Your answer should be compact. 0.94. What is the ratio of the Enrollment rate (%) of Swaziland in 1993 to that in 2001?
Ensure brevity in your answer.  1.01. What is the ratio of the Enrollment rate (%) of East Asia (developing only) in 1994 to that in 1995?
Your answer should be compact. 1.01. What is the ratio of the Enrollment rate (%) of Burkina Faso in 1994 to that in 1995?
Your answer should be very brief. 0.95. What is the ratio of the Enrollment rate (%) in Greece in 1994 to that in 1995?
Give a very brief answer. 0.98. What is the ratio of the Enrollment rate (%) of East Asia (developing only) in 1994 to that in 1998?
Provide a succinct answer. 0.97. What is the ratio of the Enrollment rate (%) of Burkina Faso in 1994 to that in 1998?
Provide a succinct answer. 0.84. What is the ratio of the Enrollment rate (%) in Greece in 1994 to that in 1998?
Your response must be concise. 0.94. What is the ratio of the Enrollment rate (%) in Swaziland in 1994 to that in 1998?
Your response must be concise. 1.03. What is the ratio of the Enrollment rate (%) of East Asia (developing only) in 1994 to that in 1999?
Your response must be concise. 0.94. What is the ratio of the Enrollment rate (%) in Burkina Faso in 1994 to that in 1999?
Make the answer very short. 0.82. What is the ratio of the Enrollment rate (%) of Greece in 1994 to that in 1999?
Your answer should be compact. 0.94. What is the ratio of the Enrollment rate (%) of Swaziland in 1994 to that in 1999?
Provide a short and direct response. 1.04. What is the ratio of the Enrollment rate (%) in East Asia (developing only) in 1994 to that in 2000?
Provide a short and direct response. 0.94. What is the ratio of the Enrollment rate (%) in Burkina Faso in 1994 to that in 2000?
Your response must be concise. 0.78. What is the ratio of the Enrollment rate (%) in Greece in 1994 to that in 2000?
Keep it short and to the point. 0.92. What is the ratio of the Enrollment rate (%) in Swaziland in 1994 to that in 2000?
Your response must be concise. 1.03. What is the ratio of the Enrollment rate (%) of Burkina Faso in 1994 to that in 2001?
Offer a terse response. 0.75. What is the ratio of the Enrollment rate (%) of Greece in 1994 to that in 2001?
Your answer should be very brief. 0.93. What is the ratio of the Enrollment rate (%) in Swaziland in 1994 to that in 2001?
Keep it short and to the point. 1.02. What is the ratio of the Enrollment rate (%) in East Asia (developing only) in 1995 to that in 1998?
Make the answer very short. 0.97. What is the ratio of the Enrollment rate (%) in Burkina Faso in 1995 to that in 1998?
Offer a terse response. 0.88. What is the ratio of the Enrollment rate (%) of Greece in 1995 to that in 1998?
Offer a terse response. 0.96. What is the ratio of the Enrollment rate (%) of Swaziland in 1995 to that in 1998?
Your answer should be very brief. 1.04. What is the ratio of the Enrollment rate (%) in East Asia (developing only) in 1995 to that in 1999?
Provide a short and direct response. 0.94. What is the ratio of the Enrollment rate (%) of Burkina Faso in 1995 to that in 1999?
Offer a terse response. 0.86. What is the ratio of the Enrollment rate (%) of Greece in 1995 to that in 1999?
Offer a terse response. 0.95. What is the ratio of the Enrollment rate (%) of Swaziland in 1995 to that in 1999?
Make the answer very short. 1.05. What is the ratio of the Enrollment rate (%) of East Asia (developing only) in 1995 to that in 2000?
Your answer should be compact. 0.93. What is the ratio of the Enrollment rate (%) of Burkina Faso in 1995 to that in 2000?
Keep it short and to the point. 0.82. What is the ratio of the Enrollment rate (%) in Greece in 1995 to that in 2000?
Provide a short and direct response. 0.94. What is the ratio of the Enrollment rate (%) of Swaziland in 1995 to that in 2000?
Keep it short and to the point. 1.04. What is the ratio of the Enrollment rate (%) in East Asia (developing only) in 1995 to that in 2001?
Keep it short and to the point. 0.93. What is the ratio of the Enrollment rate (%) in Burkina Faso in 1995 to that in 2001?
Offer a very short reply. 0.79. What is the ratio of the Enrollment rate (%) in Greece in 1995 to that in 2001?
Ensure brevity in your answer.  0.95. What is the ratio of the Enrollment rate (%) of Swaziland in 1995 to that in 2001?
Provide a succinct answer. 1.03. What is the ratio of the Enrollment rate (%) in East Asia (developing only) in 1998 to that in 1999?
Your answer should be compact. 0.97. What is the ratio of the Enrollment rate (%) in Burkina Faso in 1998 to that in 1999?
Offer a very short reply. 0.97. What is the ratio of the Enrollment rate (%) in Greece in 1998 to that in 1999?
Offer a very short reply. 1. What is the ratio of the Enrollment rate (%) in Swaziland in 1998 to that in 1999?
Your answer should be compact. 1.01. What is the ratio of the Enrollment rate (%) of East Asia (developing only) in 1998 to that in 2000?
Keep it short and to the point. 0.97. What is the ratio of the Enrollment rate (%) in Burkina Faso in 1998 to that in 2000?
Your answer should be compact. 0.93. What is the ratio of the Enrollment rate (%) of Greece in 1998 to that in 2000?
Offer a terse response. 0.98. What is the ratio of the Enrollment rate (%) of East Asia (developing only) in 1998 to that in 2001?
Provide a short and direct response. 0.96. What is the ratio of the Enrollment rate (%) of Burkina Faso in 1998 to that in 2001?
Offer a very short reply. 0.9. What is the ratio of the Enrollment rate (%) in Greece in 1998 to that in 2001?
Your response must be concise. 0.99. What is the ratio of the Enrollment rate (%) in East Asia (developing only) in 1999 to that in 2000?
Give a very brief answer. 1. What is the ratio of the Enrollment rate (%) of Burkina Faso in 1999 to that in 2000?
Offer a very short reply. 0.96. What is the ratio of the Enrollment rate (%) in Greece in 1999 to that in 2000?
Make the answer very short. 0.99. What is the ratio of the Enrollment rate (%) in Swaziland in 1999 to that in 2000?
Provide a short and direct response. 0.99. What is the ratio of the Enrollment rate (%) of East Asia (developing only) in 1999 to that in 2001?
Make the answer very short. 0.99. What is the ratio of the Enrollment rate (%) of Burkina Faso in 1999 to that in 2001?
Provide a succinct answer. 0.92. What is the ratio of the Enrollment rate (%) in Swaziland in 1999 to that in 2001?
Provide a succinct answer. 0.98. What is the ratio of the Enrollment rate (%) in East Asia (developing only) in 2000 to that in 2001?
Offer a very short reply. 1. What is the ratio of the Enrollment rate (%) of Burkina Faso in 2000 to that in 2001?
Your response must be concise. 0.96. What is the ratio of the Enrollment rate (%) of Greece in 2000 to that in 2001?
Provide a succinct answer. 1.01. What is the ratio of the Enrollment rate (%) of Swaziland in 2000 to that in 2001?
Offer a very short reply. 0.99. What is the difference between the highest and the second highest Enrollment rate (%) of East Asia (developing only)?
Offer a terse response. 0.43. What is the difference between the highest and the second highest Enrollment rate (%) in Burkina Faso?
Your response must be concise. 1.18. What is the difference between the highest and the second highest Enrollment rate (%) of Greece?
Your answer should be compact. 0.71. What is the difference between the highest and the second highest Enrollment rate (%) of Swaziland?
Provide a short and direct response. 0.5. What is the difference between the highest and the lowest Enrollment rate (%) of East Asia (developing only)?
Provide a succinct answer. 6.69. What is the difference between the highest and the lowest Enrollment rate (%) of Burkina Faso?
Give a very brief answer. 9.72. What is the difference between the highest and the lowest Enrollment rate (%) of Greece?
Your answer should be very brief. 7.63. What is the difference between the highest and the lowest Enrollment rate (%) of Swaziland?
Keep it short and to the point. 4.08. 